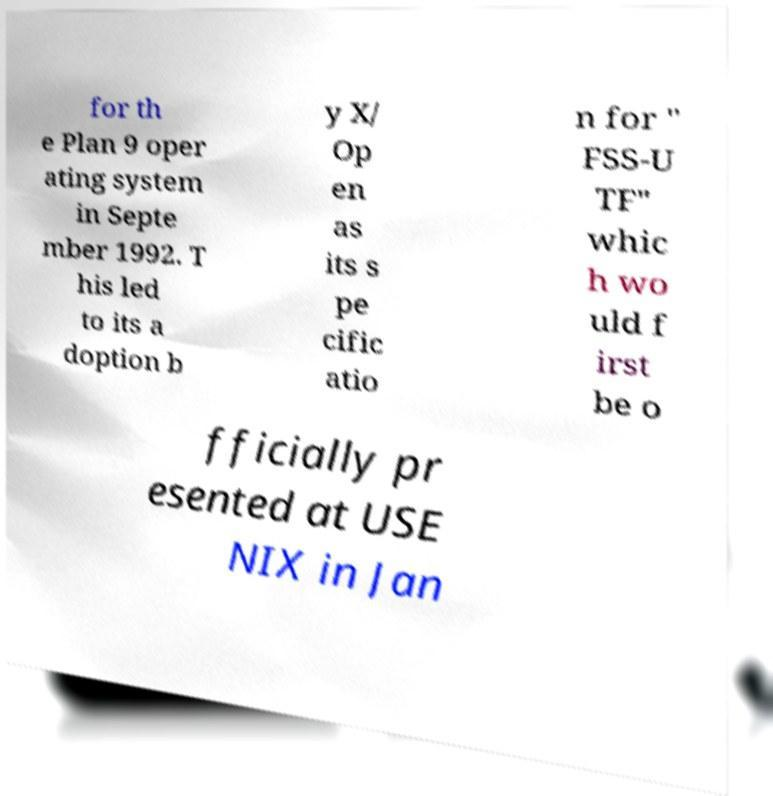Please read and relay the text visible in this image. What does it say? for th e Plan 9 oper ating system in Septe mber 1992. T his led to its a doption b y X/ Op en as its s pe cific atio n for " FSS-U TF" whic h wo uld f irst be o fficially pr esented at USE NIX in Jan 